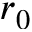<formula> <loc_0><loc_0><loc_500><loc_500>r _ { 0 }</formula> 